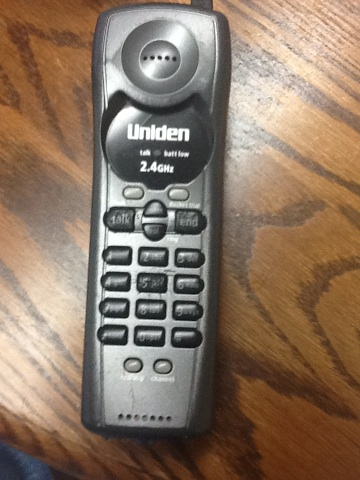Why have such devices become less common? Cordless phones like this one have become less common due to the rise of mobile phones which offer greater mobility, advanced features, and internet connectivity. Additionally, the shift towards VoIP and digital communications in both personal and business environments contributes to their declining usage. 